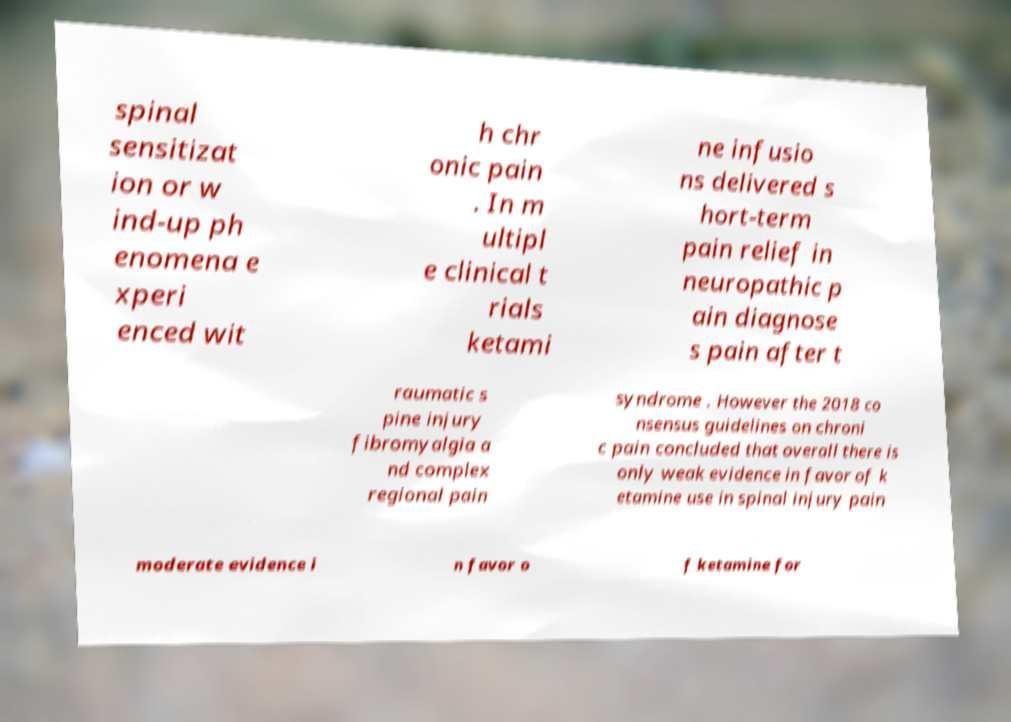There's text embedded in this image that I need extracted. Can you transcribe it verbatim? spinal sensitizat ion or w ind-up ph enomena e xperi enced wit h chr onic pain . In m ultipl e clinical t rials ketami ne infusio ns delivered s hort-term pain relief in neuropathic p ain diagnose s pain after t raumatic s pine injury fibromyalgia a nd complex regional pain syndrome . However the 2018 co nsensus guidelines on chroni c pain concluded that overall there is only weak evidence in favor of k etamine use in spinal injury pain moderate evidence i n favor o f ketamine for 